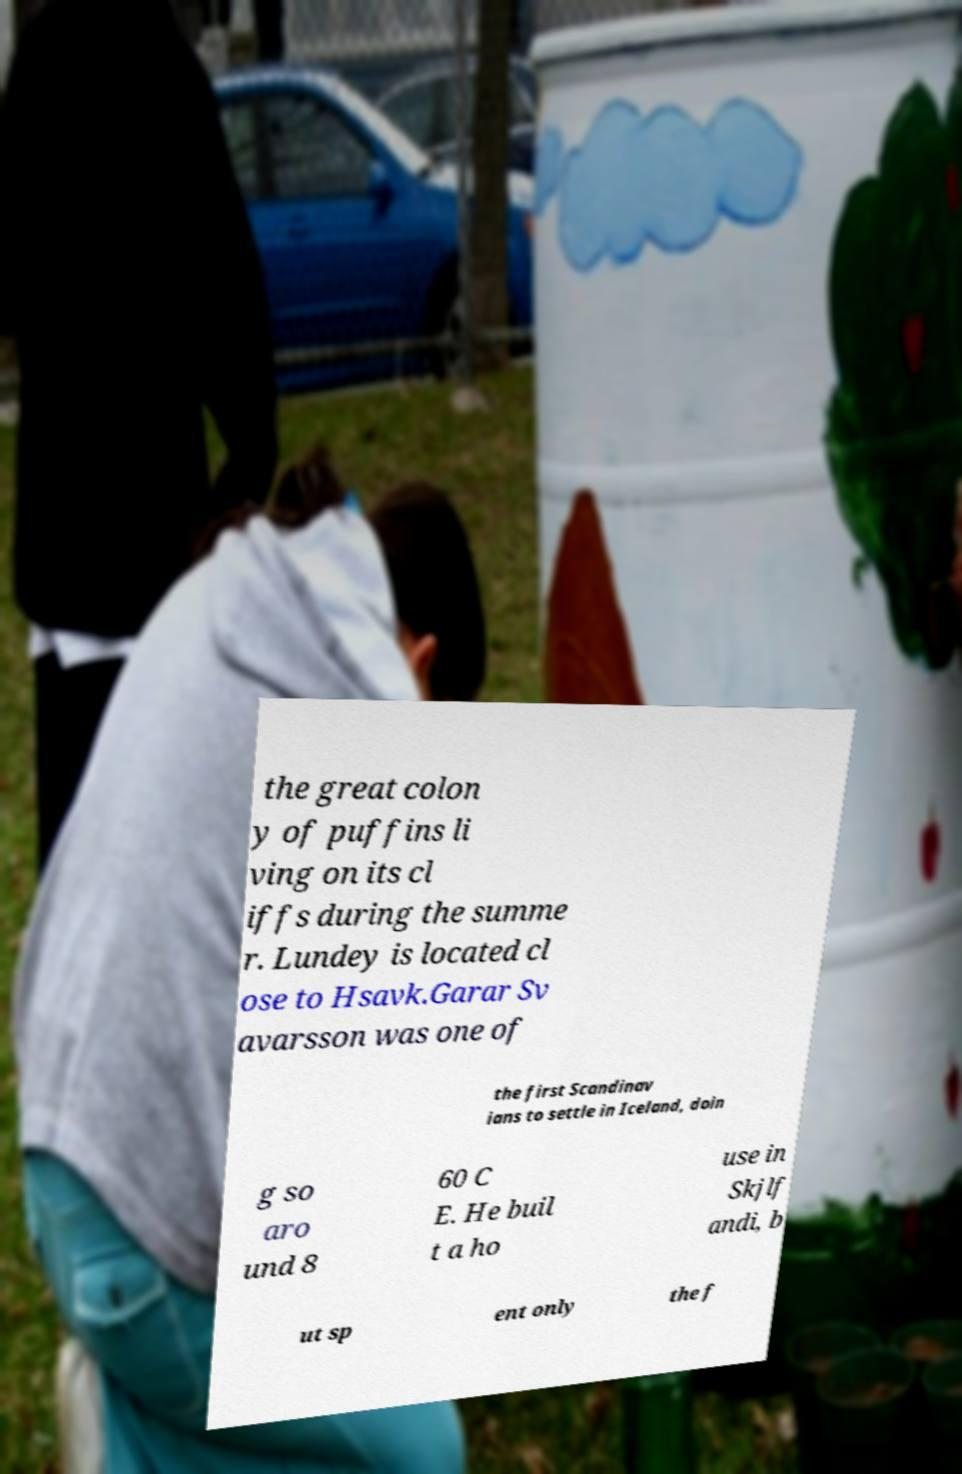For documentation purposes, I need the text within this image transcribed. Could you provide that? the great colon y of puffins li ving on its cl iffs during the summe r. Lundey is located cl ose to Hsavk.Garar Sv avarsson was one of the first Scandinav ians to settle in Iceland, doin g so aro und 8 60 C E. He buil t a ho use in Skjlf andi, b ut sp ent only the f 